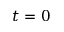Convert formula to latex. <formula><loc_0><loc_0><loc_500><loc_500>t = 0</formula> 